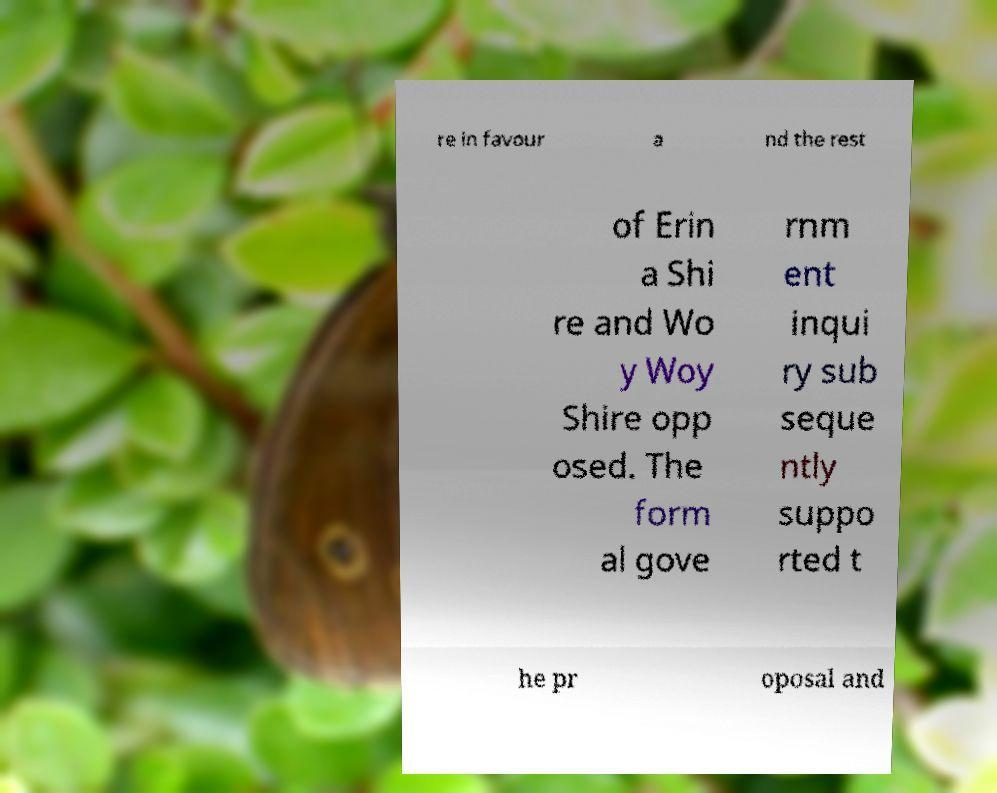Please read and relay the text visible in this image. What does it say? re in favour a nd the rest of Erin a Shi re and Wo y Woy Shire opp osed. The form al gove rnm ent inqui ry sub seque ntly suppo rted t he pr oposal and 